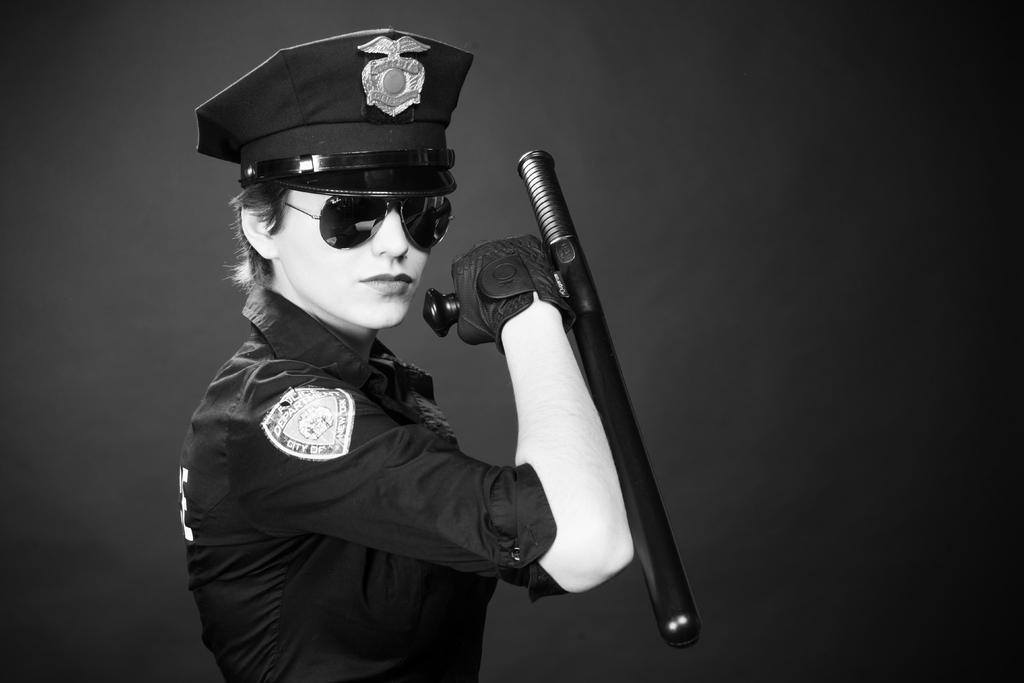Please provide a concise description of this image. There is a girl in a uniform holding an object in the foreground area of the image and the background is black. 